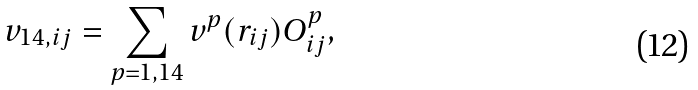Convert formula to latex. <formula><loc_0><loc_0><loc_500><loc_500>v _ { 1 4 , i j } = \sum _ { p = 1 , 1 4 } v ^ { p } ( r _ { i j } ) O ^ { p } _ { i j } ,</formula> 